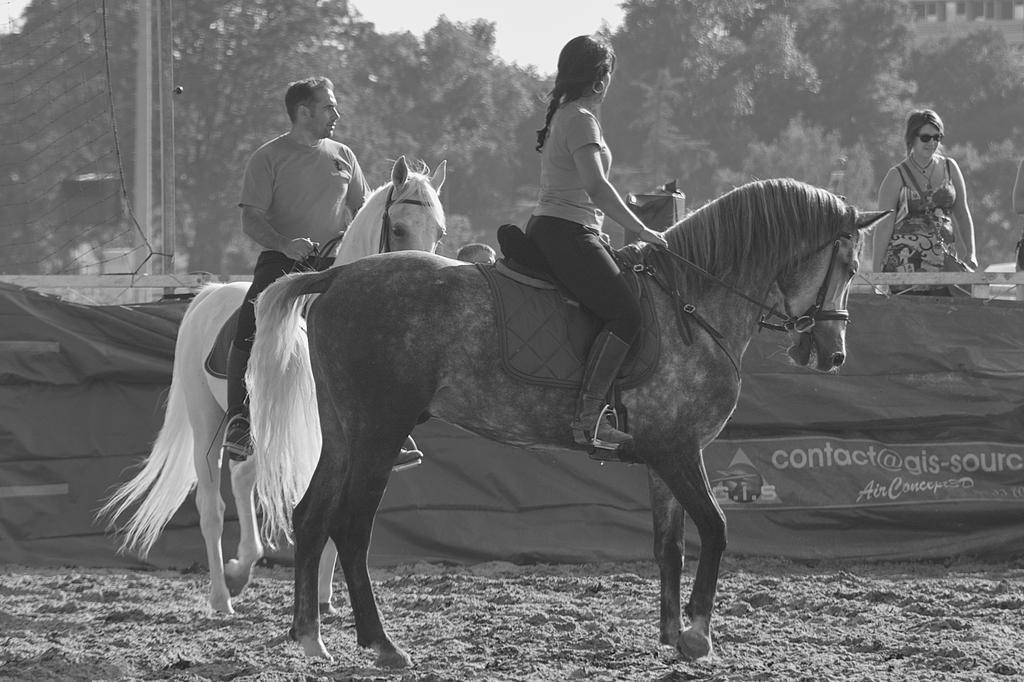Please provide a concise description of this image. In this image I see a man and a woman, who are sitting on the horse and In the background I see lot of trees and a woman. 